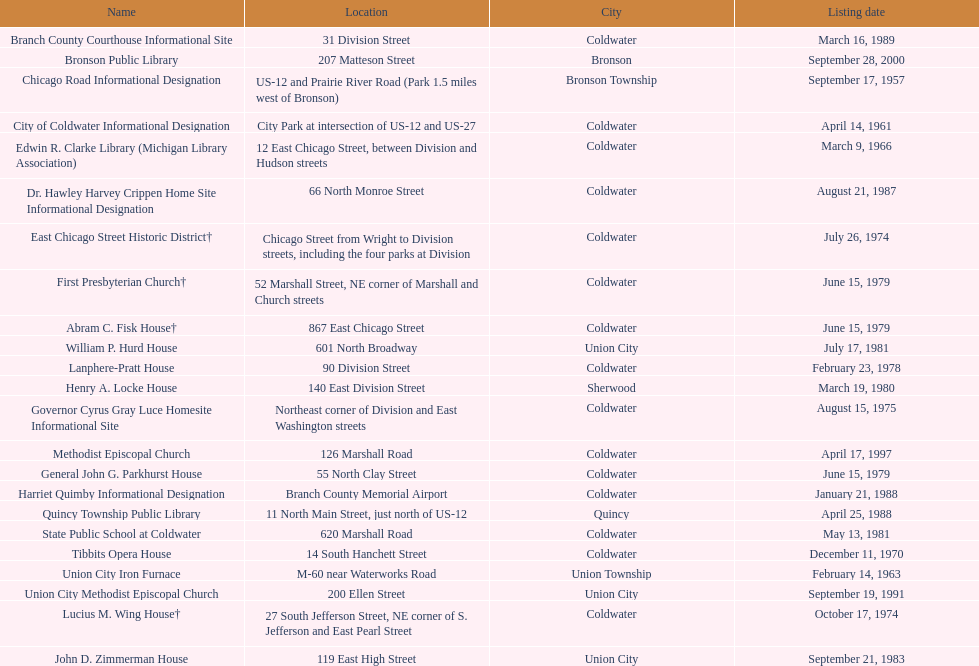How many sites were listed as historical before 1980? 12. Could you help me parse every detail presented in this table? {'header': ['Name', 'Location', 'City', 'Listing date'], 'rows': [['Branch County Courthouse Informational Site', '31 Division Street', 'Coldwater', 'March 16, 1989'], ['Bronson Public Library', '207 Matteson Street', 'Bronson', 'September 28, 2000'], ['Chicago Road Informational Designation', 'US-12 and Prairie River Road (Park 1.5 miles west of Bronson)', 'Bronson Township', 'September 17, 1957'], ['City of Coldwater Informational Designation', 'City Park at intersection of US-12 and US-27', 'Coldwater', 'April 14, 1961'], ['Edwin R. Clarke Library (Michigan Library Association)', '12 East Chicago Street, between Division and Hudson streets', 'Coldwater', 'March 9, 1966'], ['Dr. Hawley Harvey Crippen Home Site Informational Designation', '66 North Monroe Street', 'Coldwater', 'August 21, 1987'], ['East Chicago Street Historic District†', 'Chicago Street from Wright to Division streets, including the four parks at Division', 'Coldwater', 'July 26, 1974'], ['First Presbyterian Church†', '52 Marshall Street, NE corner of Marshall and Church streets', 'Coldwater', 'June 15, 1979'], ['Abram C. Fisk House†', '867 East Chicago Street', 'Coldwater', 'June 15, 1979'], ['William P. Hurd House', '601 North Broadway', 'Union City', 'July 17, 1981'], ['Lanphere-Pratt House', '90 Division Street', 'Coldwater', 'February 23, 1978'], ['Henry A. Locke House', '140 East Division Street', 'Sherwood', 'March 19, 1980'], ['Governor Cyrus Gray Luce Homesite Informational Site', 'Northeast corner of Division and East Washington streets', 'Coldwater', 'August 15, 1975'], ['Methodist Episcopal Church', '126 Marshall Road', 'Coldwater', 'April 17, 1997'], ['General John G. Parkhurst House', '55 North Clay Street', 'Coldwater', 'June 15, 1979'], ['Harriet Quimby Informational Designation', 'Branch County Memorial Airport', 'Coldwater', 'January 21, 1988'], ['Quincy Township Public Library', '11 North Main Street, just north of US-12', 'Quincy', 'April 25, 1988'], ['State Public School at Coldwater', '620 Marshall Road', 'Coldwater', 'May 13, 1981'], ['Tibbits Opera House', '14 South Hanchett Street', 'Coldwater', 'December 11, 1970'], ['Union City Iron Furnace', 'M-60 near Waterworks Road', 'Union Township', 'February 14, 1963'], ['Union City Methodist Episcopal Church', '200 Ellen Street', 'Union City', 'September 19, 1991'], ['Lucius M. Wing House†', '27 South Jefferson Street, NE corner of S. Jefferson and East Pearl Street', 'Coldwater', 'October 17, 1974'], ['John D. Zimmerman House', '119 East High Street', 'Union City', 'September 21, 1983']]} 